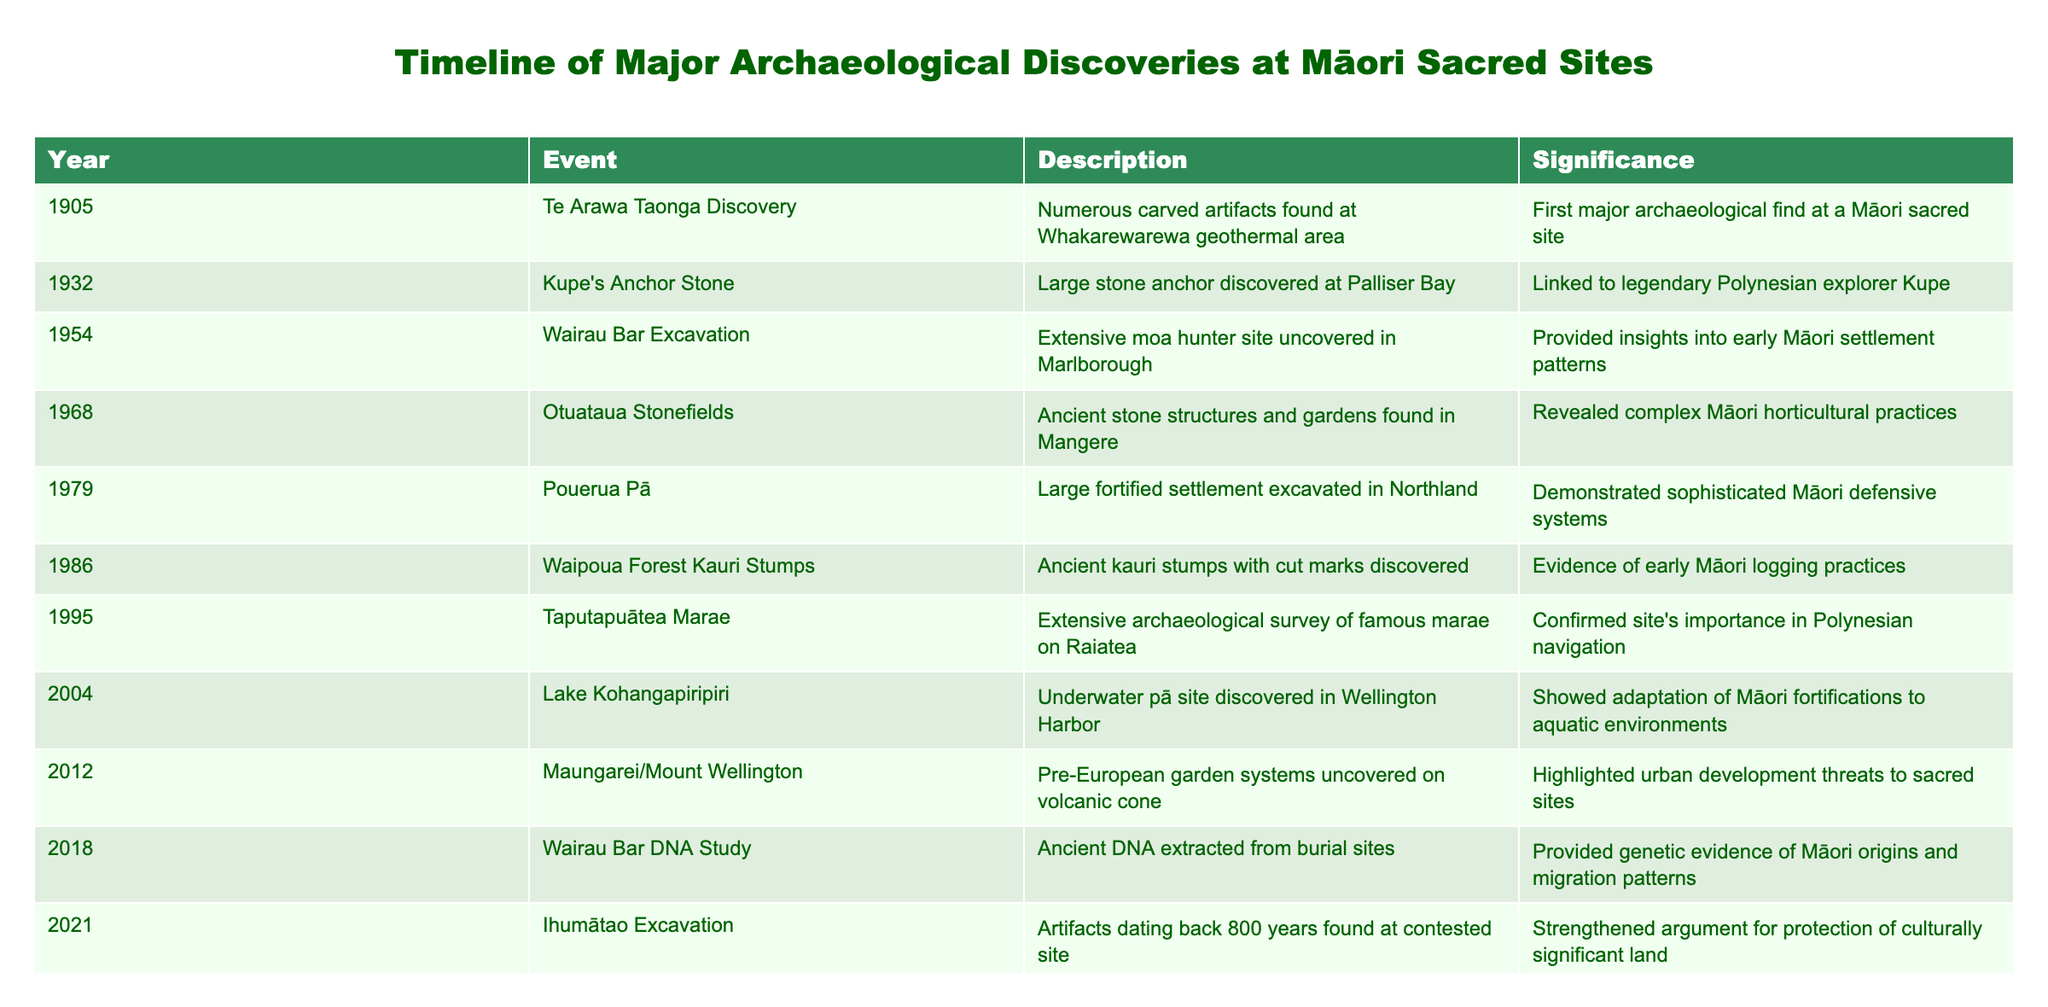What year was the Te Arawa Taonga Discovery made? The table lists the Te Arawa Taonga Discovery as occurring in 1905. This is found in the 'Year' column that corresponds to that event.
Answer: 1905 Which event provides evidence of early Māori logging practices? According to the table, the 'Waipoua Forest Kauri Stumps' event in 1986 is described as providing evidence of early Māori logging practices. This can be found in the 'Description' column.
Answer: Waipoua Forest Kauri Stumps How many years apart were the discoveries of Kupe's Anchor Stone and Wairau Bar Excavation? Kupe's Anchor Stone was discovered in 1932 and the Wairau Bar Excavation occurred in 1954. The difference between these two years is 1954 - 1932 = 22 years.
Answer: 22 years Is it true that the Otuataua Stonefields reveal complex Māori horticultural practices? The table states that the discovery of Otuataua Stonefields in 1968 revealed complex Māori horticultural practices. This confirms that the statement is true.
Answer: Yes What is the significance of the Ihumātao Excavation? The Ihumātao Excavation, which happened in 2021, is significant because it includes artifacts dated back 800 years found at a contested site. This highlights its importance concerning the protection of culturally significant land, as stated in the 'Significance' column.
Answer: Strengthened argument for protection of culturally significant land Which discovery was the first major archaeological find at a Māori sacred site? The first major archaeological find at a Māori sacred site is noted in the table as the Te Arawa Taonga Discovery in 1905. This is explicitly stated in the 'Significance' column.
Answer: Te Arawa Taonga Discovery How many events listed were discovered after 2000? The events listed after the year 2000 are 'Lake Kohangapiripiri' (2004), 'Maungarei/Mount Wellington’ (2012), 'Wairau Bar DNA Study' (2018), and 'Ihumātao Excavation' (2021), making a total of four discoveries. This is calculated by counting the events with years greater than 2000.
Answer: 4 events What is the average year of discovery for the events listed in the table? To find the average, we add all the years: 1905 + 1932 + 1954 + 1968 + 1979 + 1986 + 1995 + 2004 + 2012 + 2018 + 2021 = 21798. There are 11 events, so the average is 21798 / 11 = 1981.64, which can be rounded to 1982.
Answer: 1982 Was the Taputapuātea Marae discovery important for Polynesian navigation? The table indicates that the Taputapuātea Marae event in 1995 confirmed the site's importance in Polynesian navigation, making the statement true.
Answer: Yes 